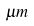Convert formula to latex. <formula><loc_0><loc_0><loc_500><loc_500>\mu m</formula> 